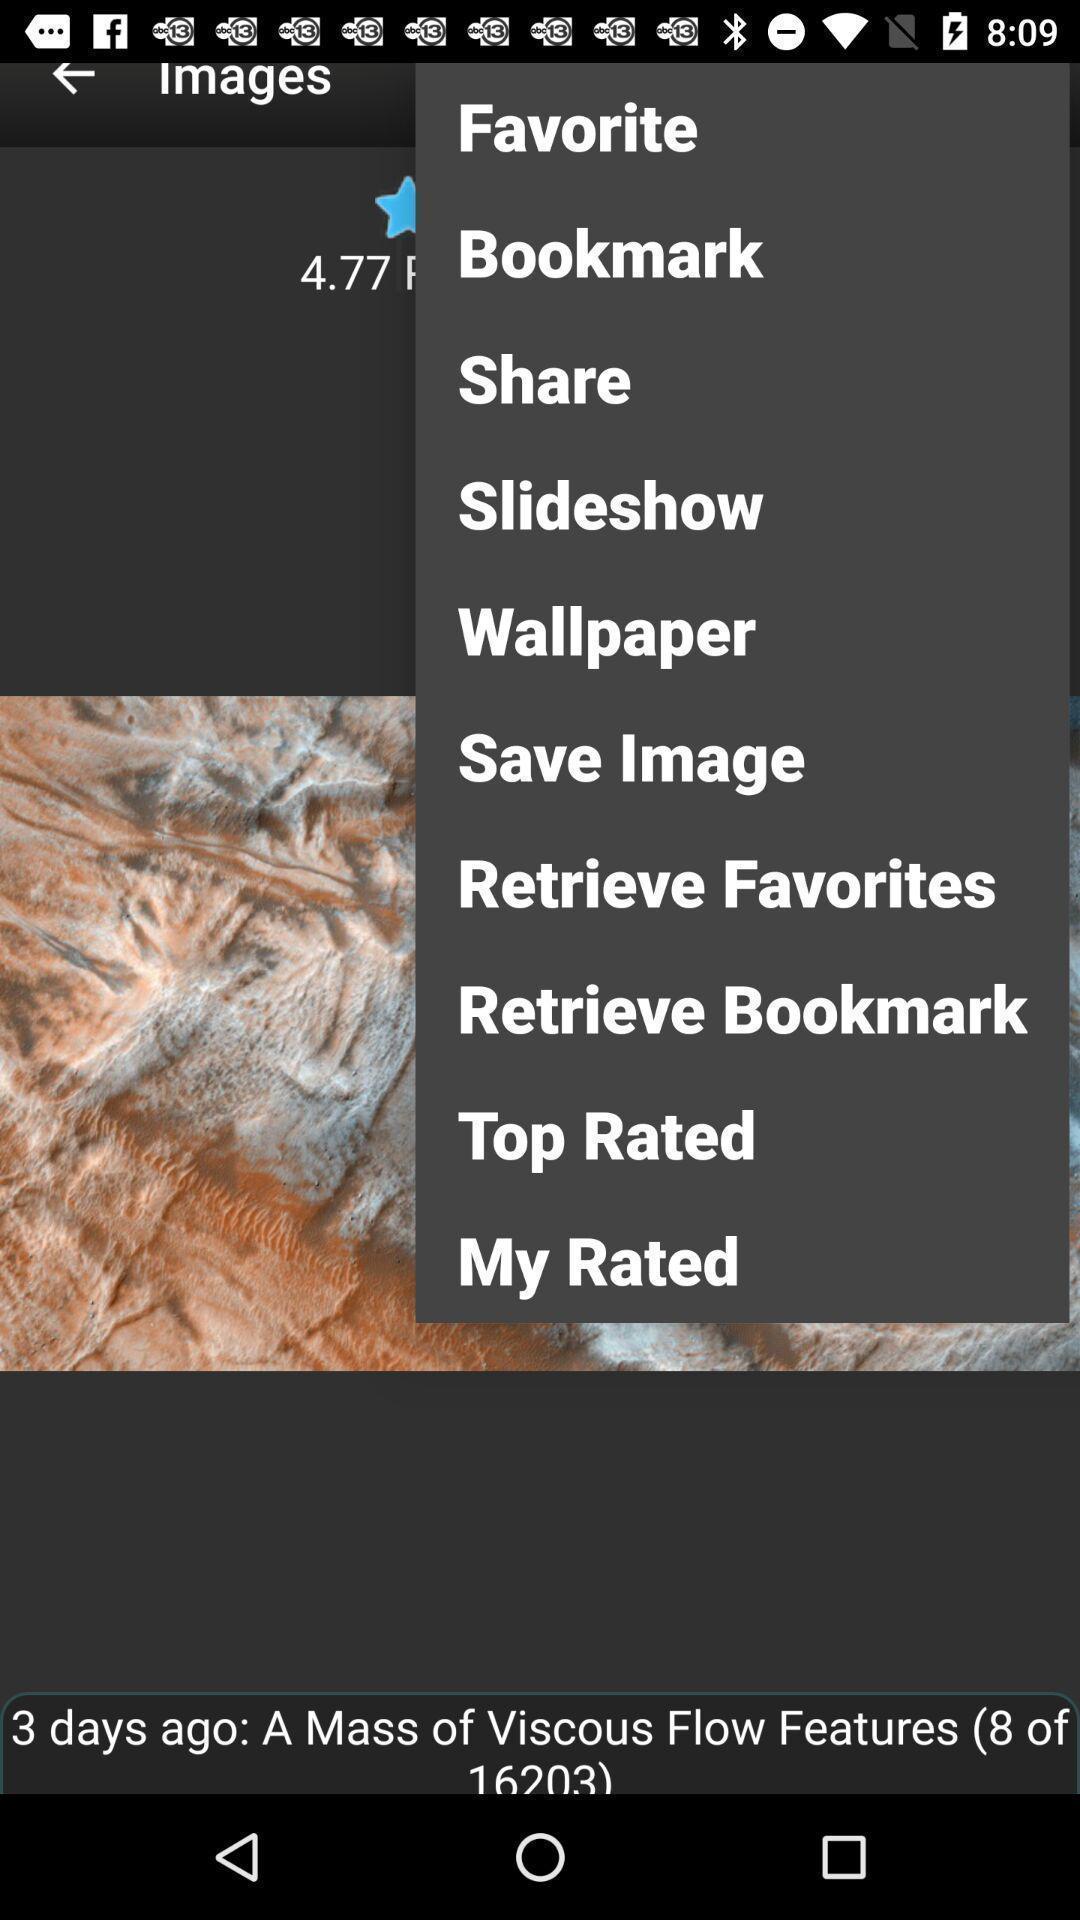Provide a description of this screenshot. Pop-up showing different options for image. 